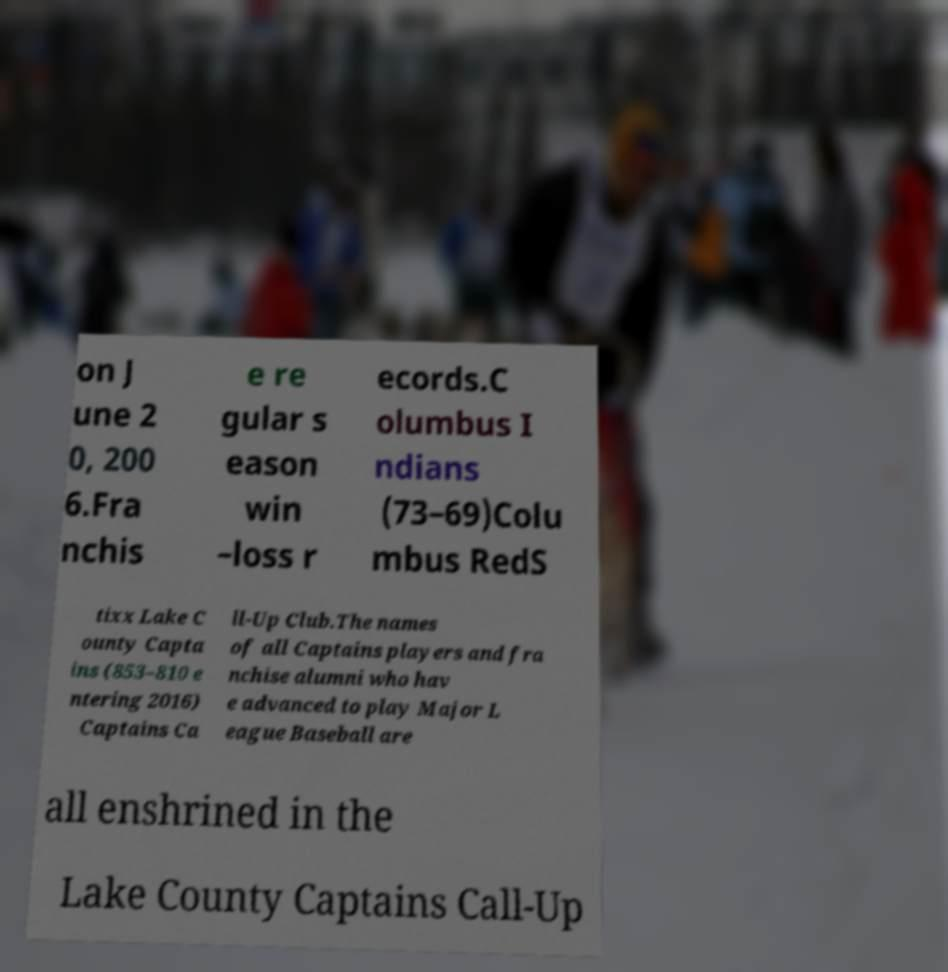For documentation purposes, I need the text within this image transcribed. Could you provide that? on J une 2 0, 200 6.Fra nchis e re gular s eason win –loss r ecords.C olumbus I ndians (73–69)Colu mbus RedS tixx Lake C ounty Capta ins (853–810 e ntering 2016) Captains Ca ll-Up Club.The names of all Captains players and fra nchise alumni who hav e advanced to play Major L eague Baseball are all enshrined in the Lake County Captains Call-Up 